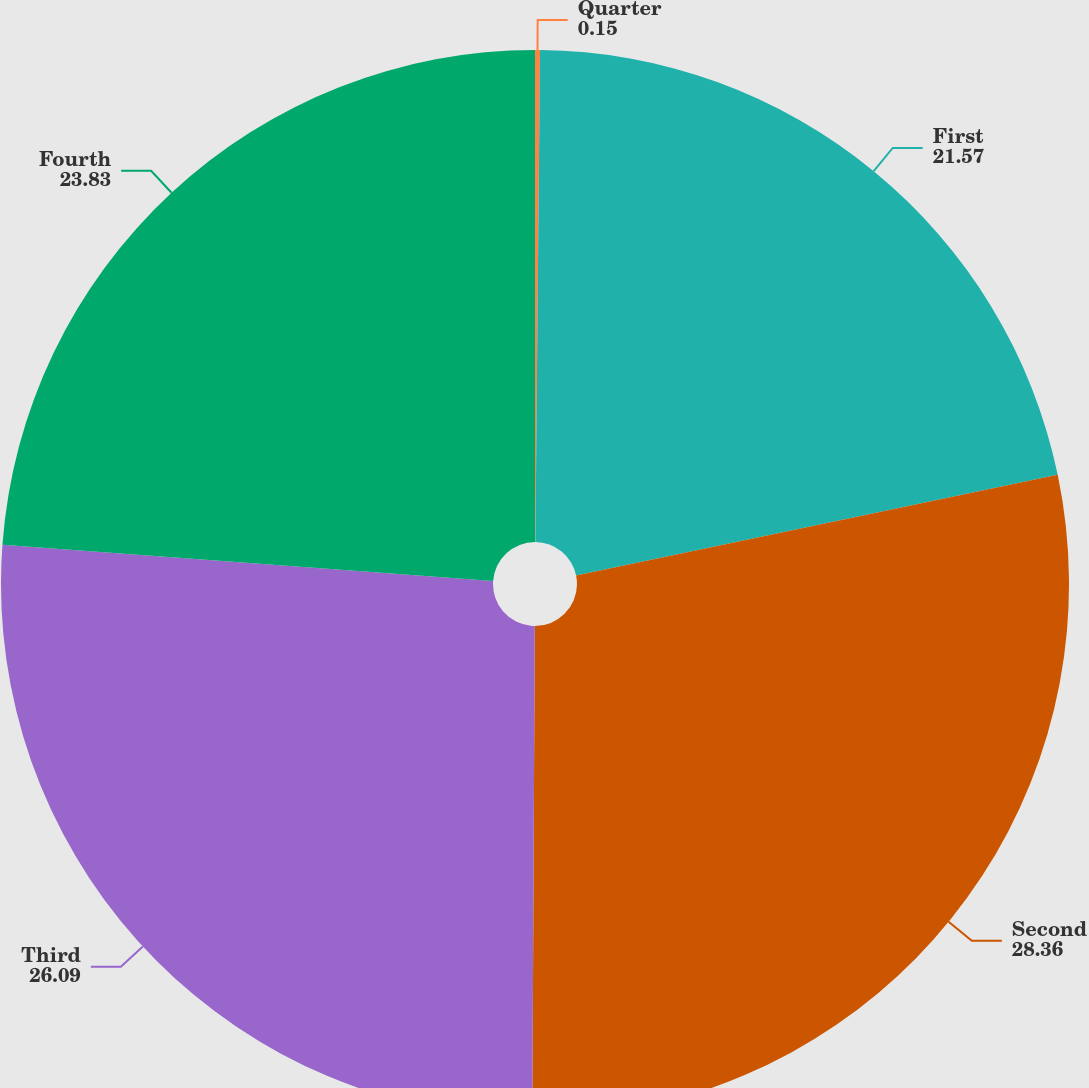Convert chart. <chart><loc_0><loc_0><loc_500><loc_500><pie_chart><fcel>Quarter<fcel>First<fcel>Second<fcel>Third<fcel>Fourth<nl><fcel>0.15%<fcel>21.57%<fcel>28.36%<fcel>26.09%<fcel>23.83%<nl></chart> 